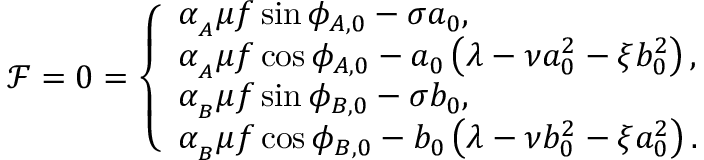Convert formula to latex. <formula><loc_0><loc_0><loc_500><loc_500>\mathcal { F } = 0 = \left \{ \begin{array} { l l } { \alpha _ { _ { A } } \mu f \sin { \phi _ { A , 0 } } - \sigma a _ { 0 } , } \\ { \alpha _ { _ { A } } \mu f \cos { \phi _ { A , 0 } } - a _ { 0 } \left ( \lambda - \nu a _ { 0 } ^ { 2 } - \xi b _ { 0 } ^ { 2 } \right ) , } \\ { \alpha _ { _ { B } } \mu f \sin { \phi _ { B , 0 } } - \sigma b _ { 0 } , } \\ { \alpha _ { _ { B } } \mu f \cos { \phi _ { B , 0 } } - b _ { 0 } \left ( \lambda - \nu b _ { 0 } ^ { 2 } - \xi a _ { 0 } ^ { 2 } \right ) . } \end{array}</formula> 